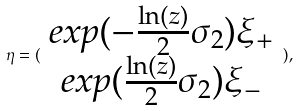<formula> <loc_0><loc_0><loc_500><loc_500>\eta = ( \begin{array} { c } e x p ( - \frac { \ln ( z ) } { 2 } \sigma _ { 2 } ) \xi _ { + } \\ e x p ( \frac { \ln ( z ) } { 2 } \sigma _ { 2 } ) \xi _ { - } \end{array} ) ,</formula> 